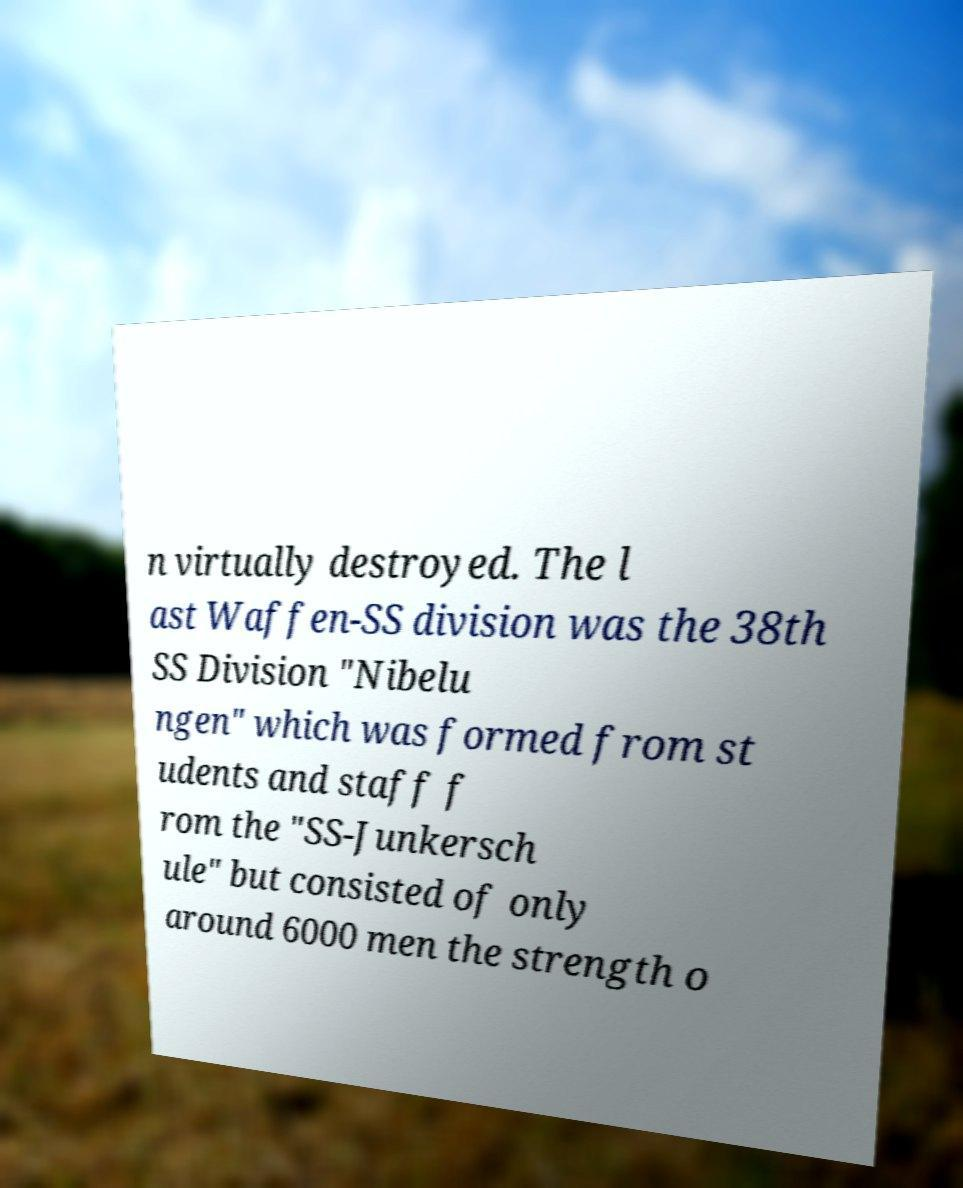There's text embedded in this image that I need extracted. Can you transcribe it verbatim? n virtually destroyed. The l ast Waffen-SS division was the 38th SS Division "Nibelu ngen" which was formed from st udents and staff f rom the "SS-Junkersch ule" but consisted of only around 6000 men the strength o 